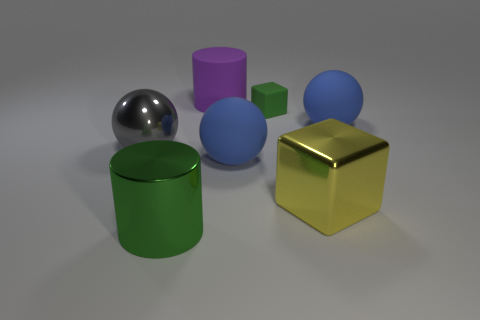Is the number of big green things behind the large yellow shiny thing greater than the number of large matte cylinders?
Your response must be concise. No. What is the color of the sphere left of the purple cylinder?
Keep it short and to the point. Gray. Do the metal ball and the green matte block have the same size?
Provide a short and direct response. No. The green cylinder has what size?
Your answer should be compact. Large. What is the shape of the other object that is the same color as the tiny thing?
Offer a very short reply. Cylinder. Is the number of big blue things greater than the number of large yellow metal objects?
Your answer should be compact. Yes. The matte thing right of the large metallic thing right of the green shiny cylinder that is in front of the big shiny sphere is what color?
Your response must be concise. Blue. Does the green object left of the large rubber cylinder have the same shape as the gray object?
Keep it short and to the point. No. There is a metal cylinder that is the same size as the yellow metallic object; what is its color?
Make the answer very short. Green. What number of small blue cubes are there?
Your answer should be compact. 0. 